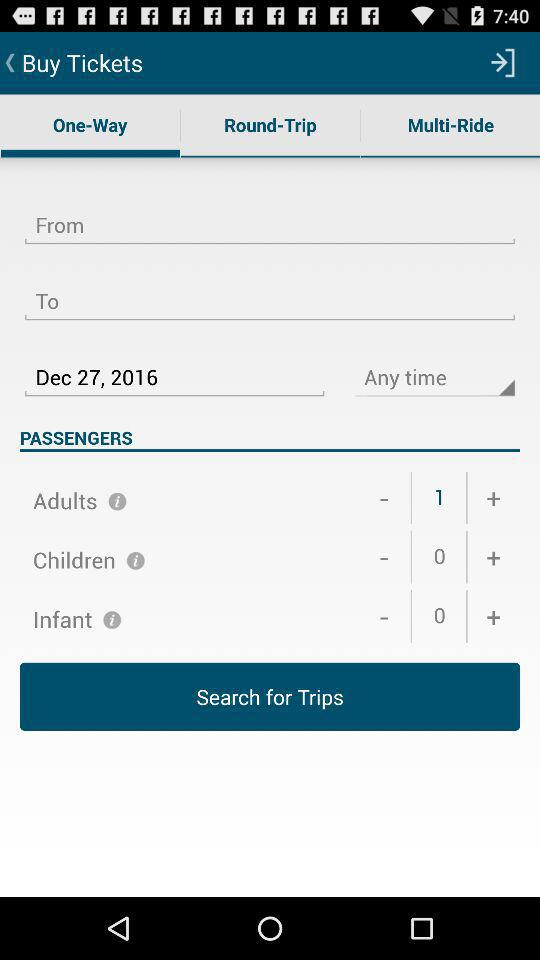What is the date? The date is December 27, 2016. 